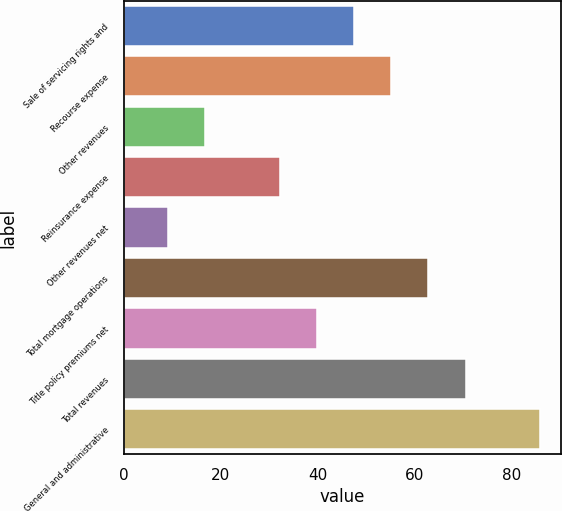Convert chart. <chart><loc_0><loc_0><loc_500><loc_500><bar_chart><fcel>Sale of servicing rights and<fcel>Recourse expense<fcel>Other revenues<fcel>Reinsurance expense<fcel>Other revenues net<fcel>Total mortgage operations<fcel>Title policy premiums net<fcel>Total revenues<fcel>General and administrative<nl><fcel>47.46<fcel>55.12<fcel>16.82<fcel>32.14<fcel>9.16<fcel>62.78<fcel>39.8<fcel>70.44<fcel>85.76<nl></chart> 